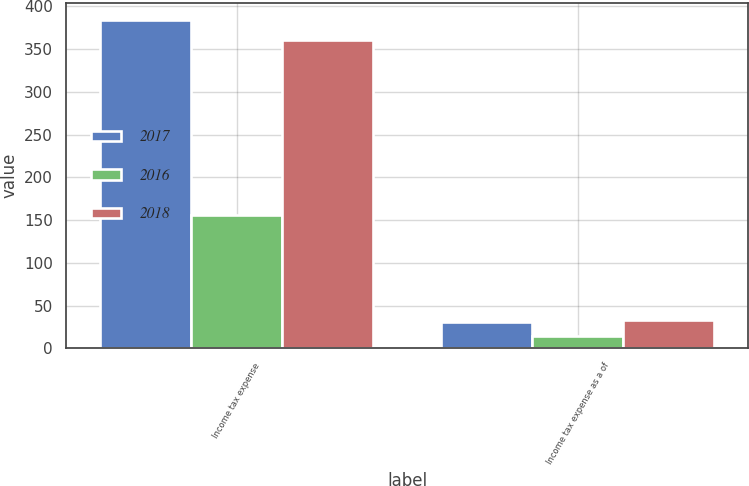<chart> <loc_0><loc_0><loc_500><loc_500><stacked_bar_chart><ecel><fcel>Income tax expense<fcel>Income tax expense as a of<nl><fcel>2017<fcel>384.4<fcel>30.3<nl><fcel>2016<fcel>155.4<fcel>14.4<nl><fcel>2018<fcel>360.7<fcel>33.6<nl></chart> 